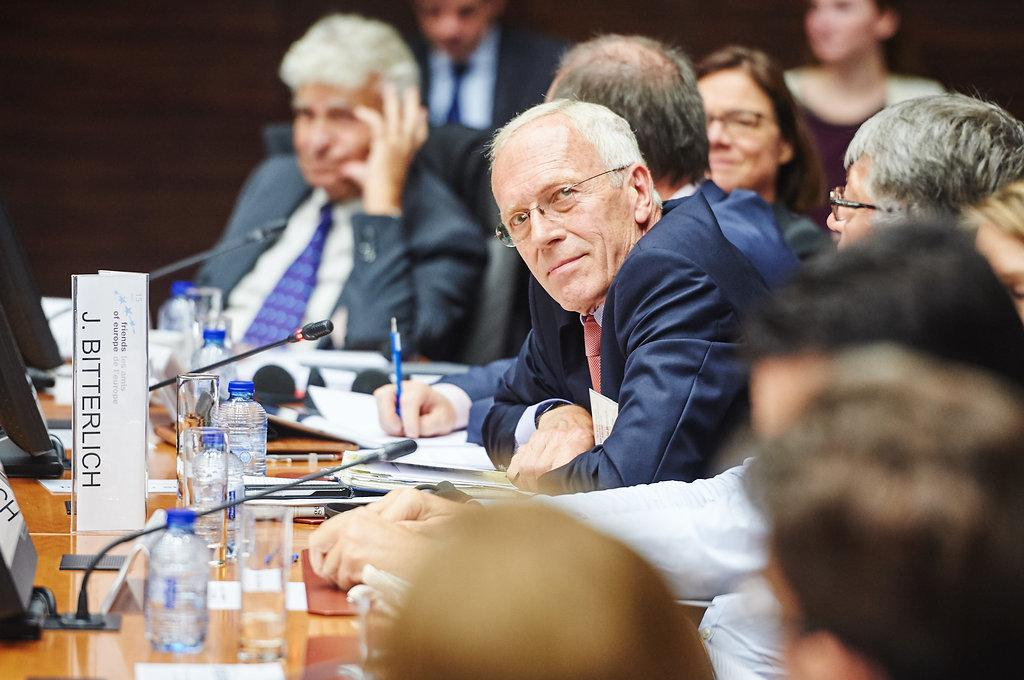What are the people in the image doing? The people in the image are sitting in front of a table. What items can be seen on the table? Microphones and bottles are visible on the table, along with other objects. Can you describe the table setting in more detail? The table has microphones and bottles, as well as other objects that are not specified. What can be observed about the background of the image? The background of the image is blurred. What type of jeans is the person wearing in the image? There is no information about jeans in the image, as the focus is on the people sitting in front of a table with microphones and bottles. Can you smell the rose in the image? There is no rose present in the image, so it cannot be smelled. 